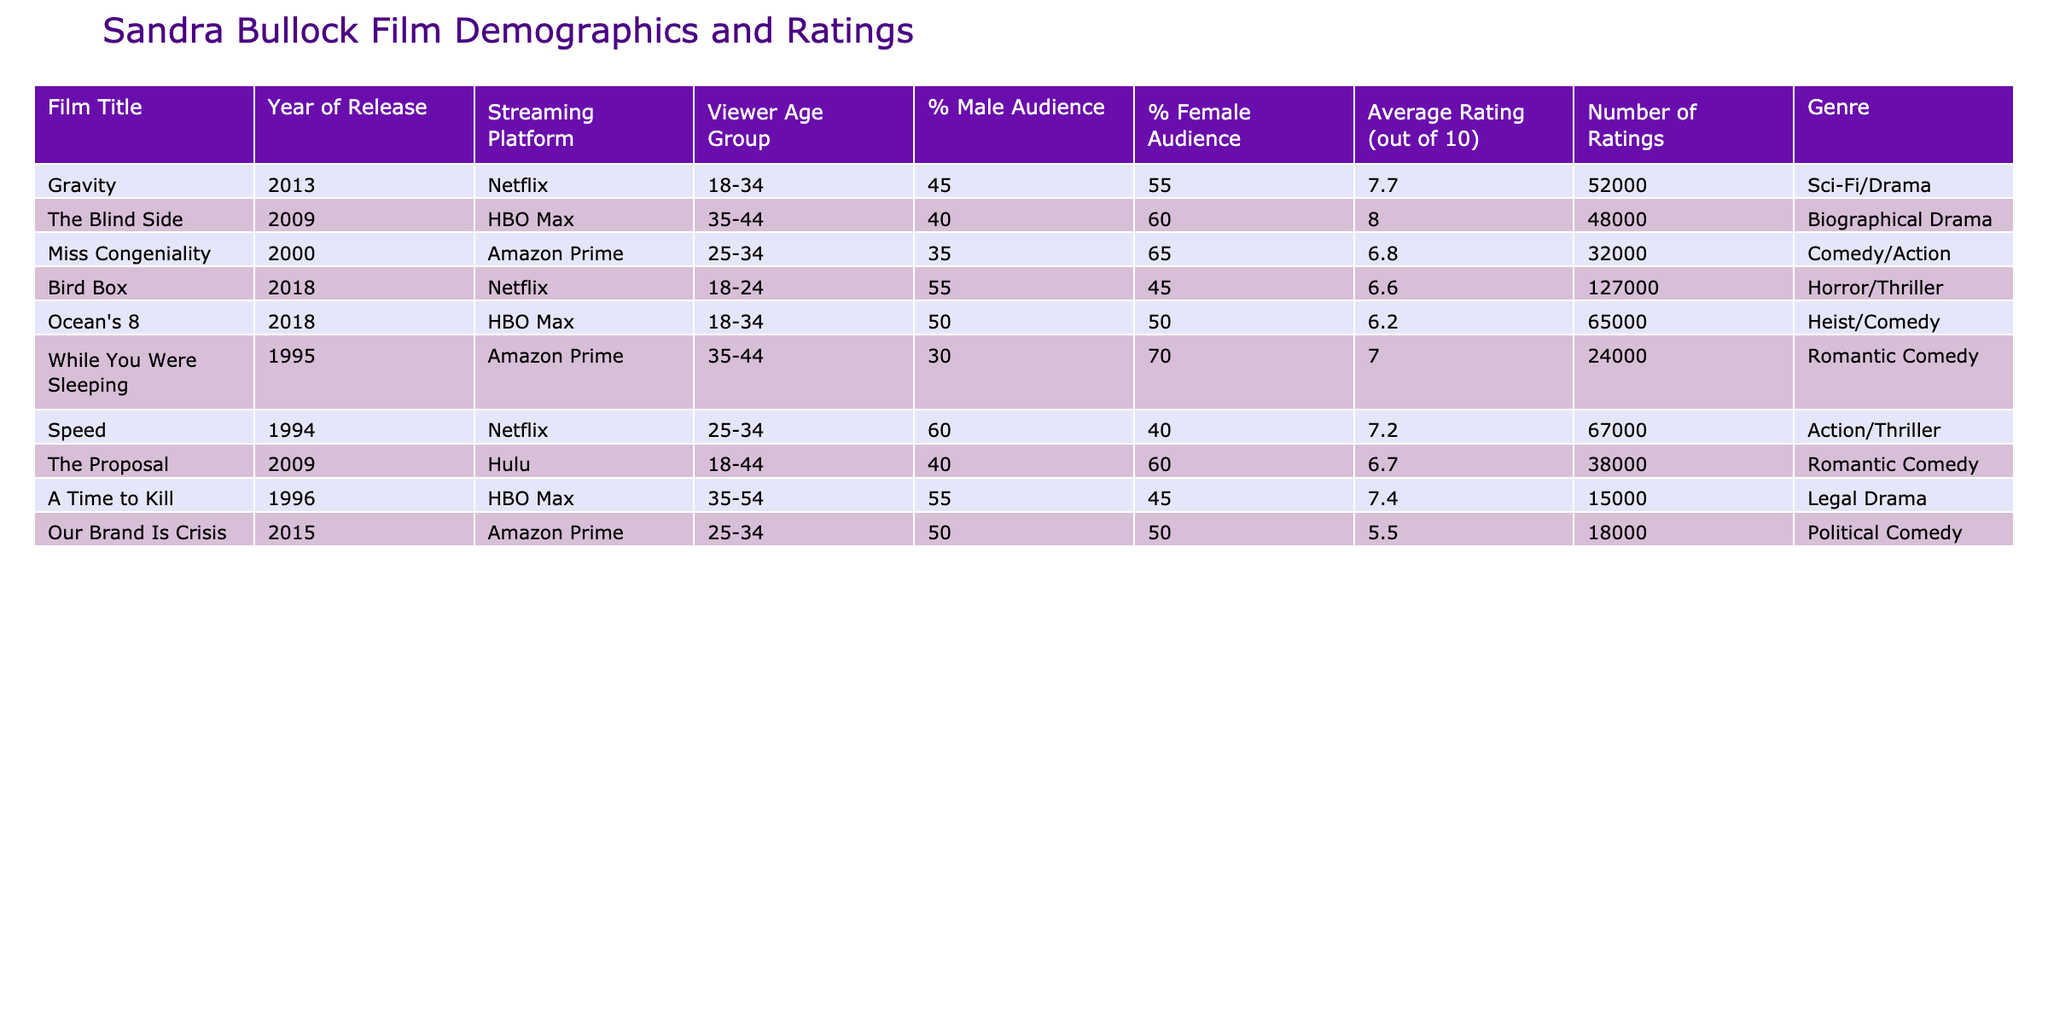What is the average rating of Sandra Bullock's films listed in the table? To find the average rating, we sum the average ratings: (7.7 + 8.0 + 6.8 + 6.6 + 6.2 + 7.0 + 7.2 + 6.7 + 7.4 + 5.5) = 68.1. There are 10 films, so the average rating is 68.1/10 = 6.81.
Answer: 6.81 Which film has the highest percentage of female audience? From the table, "Miss Congeniality" has 65% female audience, which is higher than any other films listed.
Answer: Miss Congeniality Which streaming platform features the most films in this table? Analyzing the streaming platforms: Netflix has 3 films (Gravity, Bird Box, Speed), HBO Max has 3 films (The Blind Side, Ocean's 8, A Time to Kill), Amazon Prime has 3 films (Miss Congeniality, While You Were Sleeping, Our Brand Is Crisis), and Hulu has 1 film (The Proposal). All streaming platforms listed have an equal number of films except for Hulu.
Answer: All platforms except Hulu have 3 films Is "Ocean's 8" rated higher than "The Proposal"? Comparing the ratings, "Ocean's 8" has an average rating of 6.2, while "The Proposal" has a rating of 6.7. Therefore, "The Proposal" is rated higher than "Ocean's 8."
Answer: No What is the percentage of the male audience in the film "A Time to Kill"? For "A Time to Kill," the table indicates that the percentage of the male audience is 55%.
Answer: 55% Which genre has the lowest average rating among Sandra Bullock's films in this table? We have the average ratings by genre: Sci-Fi/Drama (7.7), Biographical Drama (8.0), Comedy/Action (6.8), Horror/Thriller (6.6), Heist/Comedy (6.2), Romantic Comedy (7.0), Action/Thriller (7.2), Legal Drama (7.4), and Political Comedy (5.5). The lowest average rating is for the genre Political Comedy with a rating of 5.5.
Answer: Political Comedy What age group is most represented in the viewer demographics for Sandra Bullock's films? The table indicates that the age groups in the releases are: 18-24 (Bird Box), 18-34 (Gravity, Ocean's 8), 25-34 (Miss Congeniality, Speed, Our Brand Is Crisis), and 35-44 (The Blind Side, While You Were Sleeping), 35-54 (A Time to Kill). The age group 25-34 appears the most frequently, with 3 films.
Answer: 25-34 